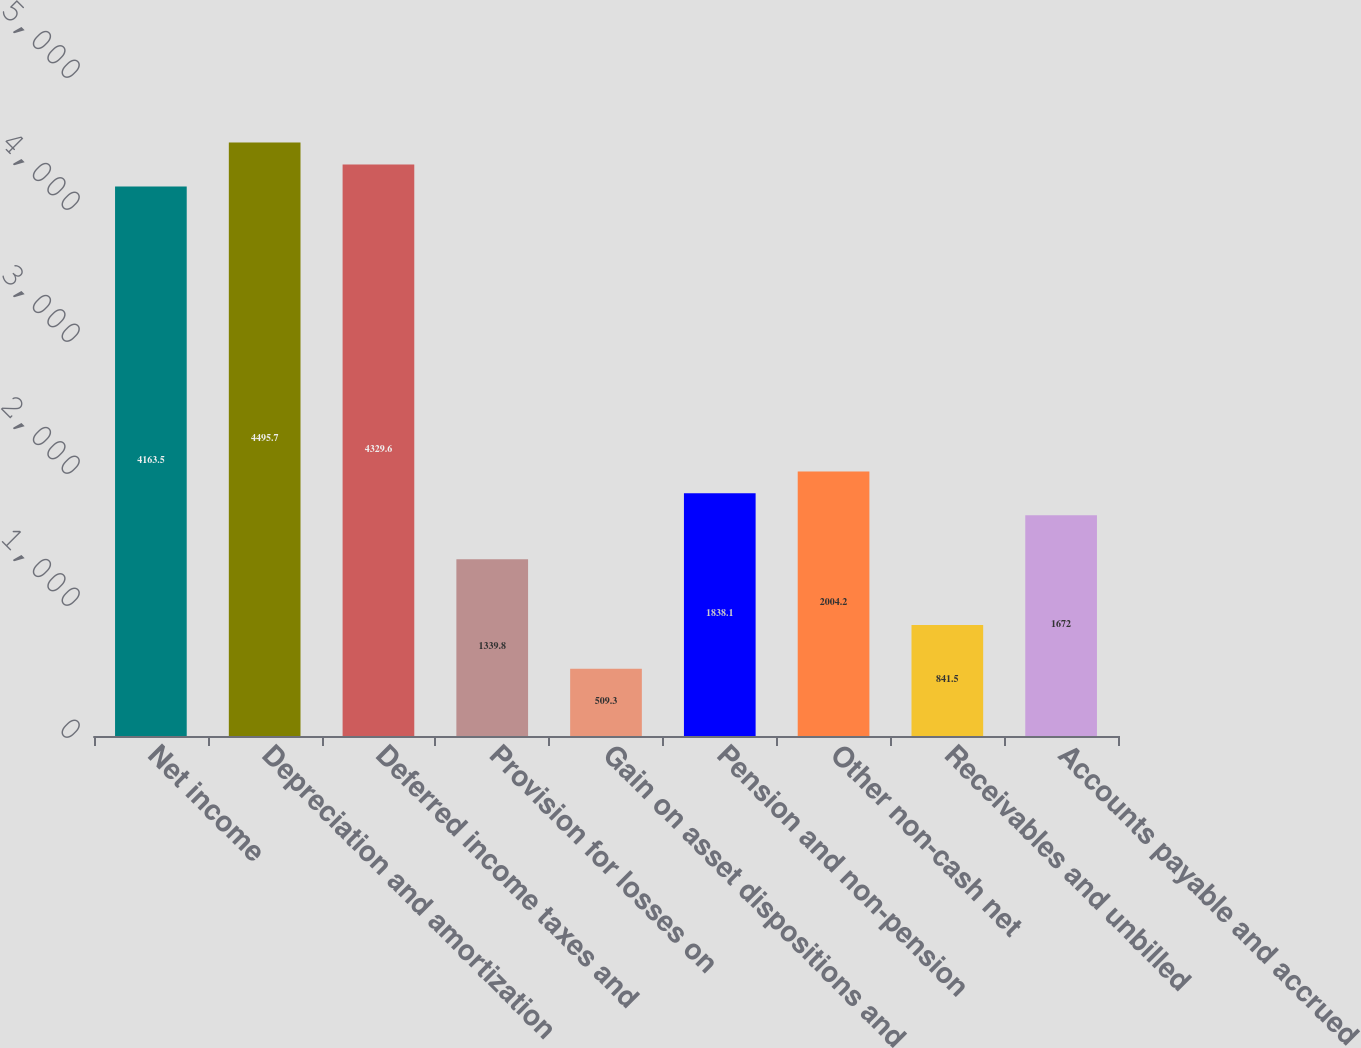Convert chart. <chart><loc_0><loc_0><loc_500><loc_500><bar_chart><fcel>Net income<fcel>Depreciation and amortization<fcel>Deferred income taxes and<fcel>Provision for losses on<fcel>Gain on asset dispositions and<fcel>Pension and non-pension<fcel>Other non-cash net<fcel>Receivables and unbilled<fcel>Accounts payable and accrued<nl><fcel>4163.5<fcel>4495.7<fcel>4329.6<fcel>1339.8<fcel>509.3<fcel>1838.1<fcel>2004.2<fcel>841.5<fcel>1672<nl></chart> 